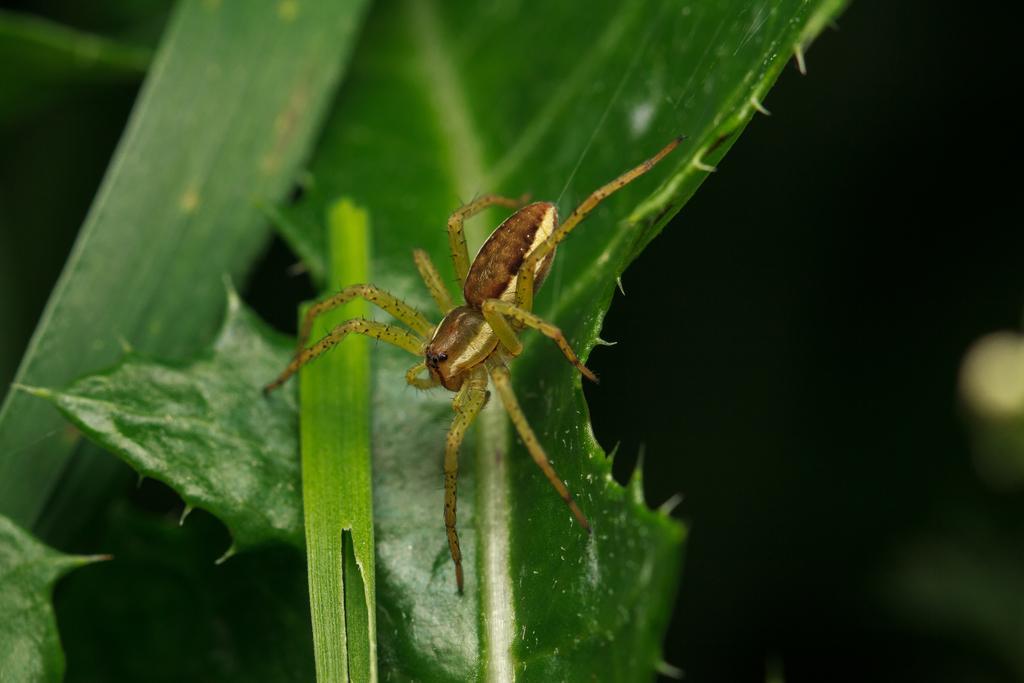Please provide a concise description of this image. In this picture there is a wolf spider in the center of the image, on a leaf. 